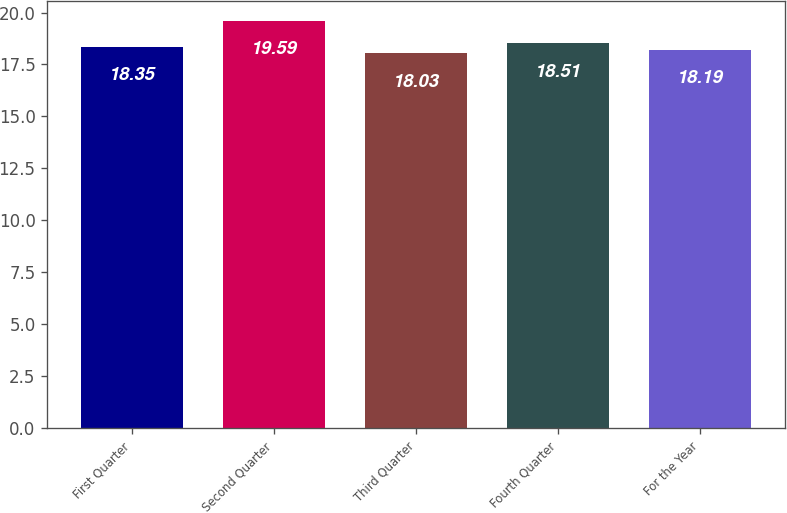Convert chart to OTSL. <chart><loc_0><loc_0><loc_500><loc_500><bar_chart><fcel>First Quarter<fcel>Second Quarter<fcel>Third Quarter<fcel>Fourth Quarter<fcel>For the Year<nl><fcel>18.35<fcel>19.59<fcel>18.03<fcel>18.51<fcel>18.19<nl></chart> 